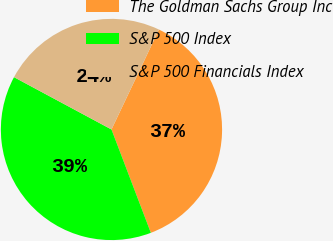<chart> <loc_0><loc_0><loc_500><loc_500><pie_chart><fcel>The Goldman Sachs Group Inc<fcel>S&P 500 Index<fcel>S&P 500 Financials Index<nl><fcel>37.14%<fcel>38.63%<fcel>24.22%<nl></chart> 